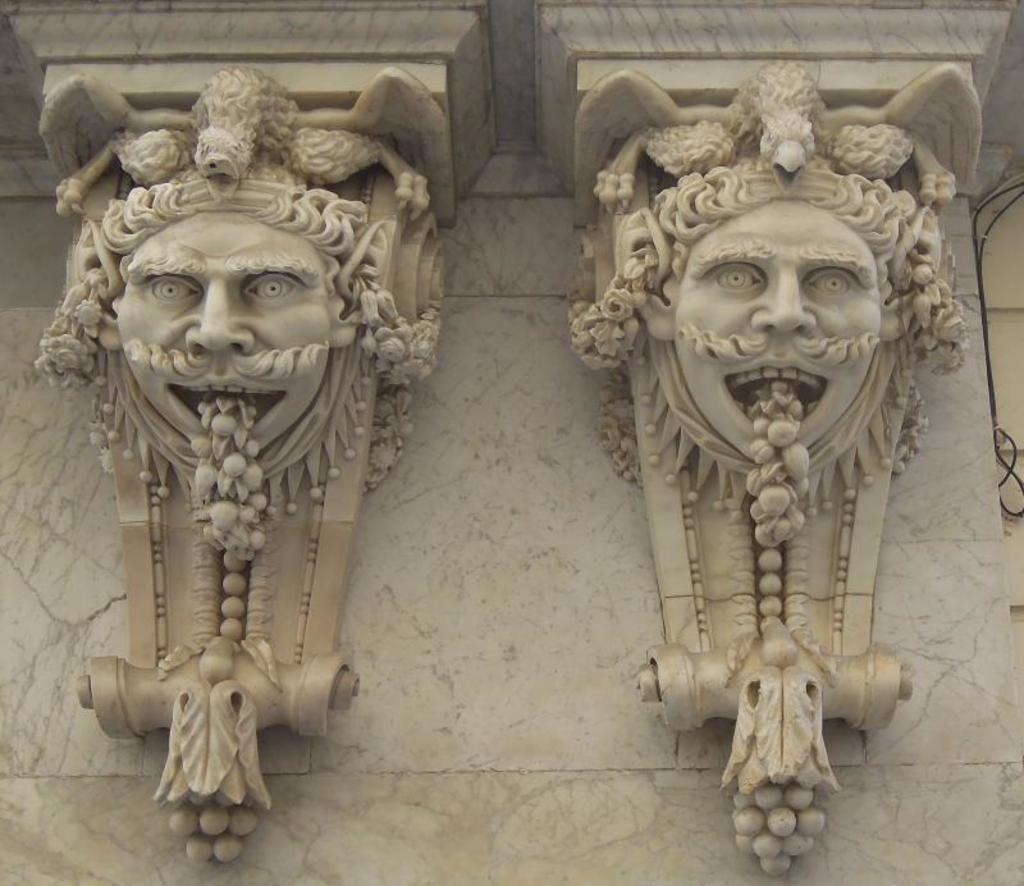What type of artwork is on the wall in the image? There are sculptures on the wall in the image. Can you describe anything else visible on the right side of the image? Yes, there is a cable visible on the right side of the image. What type of humor can be seen in the park in the image? There is no park or humor present in the image; it features sculptures on a wall and a cable on the right side. What type of street is visible in the image? There is no street visible in the image; it only shows sculptures on a wall and a cable on the right side. 